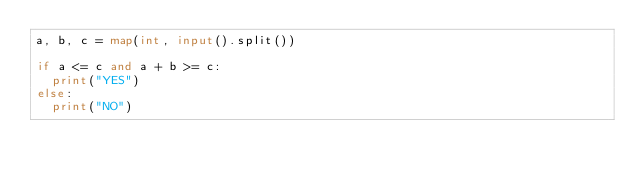<code> <loc_0><loc_0><loc_500><loc_500><_Python_>a, b, c = map(int, input().split())

if a <= c and a + b >= c:
	print("YES")
else:
	print("NO")</code> 